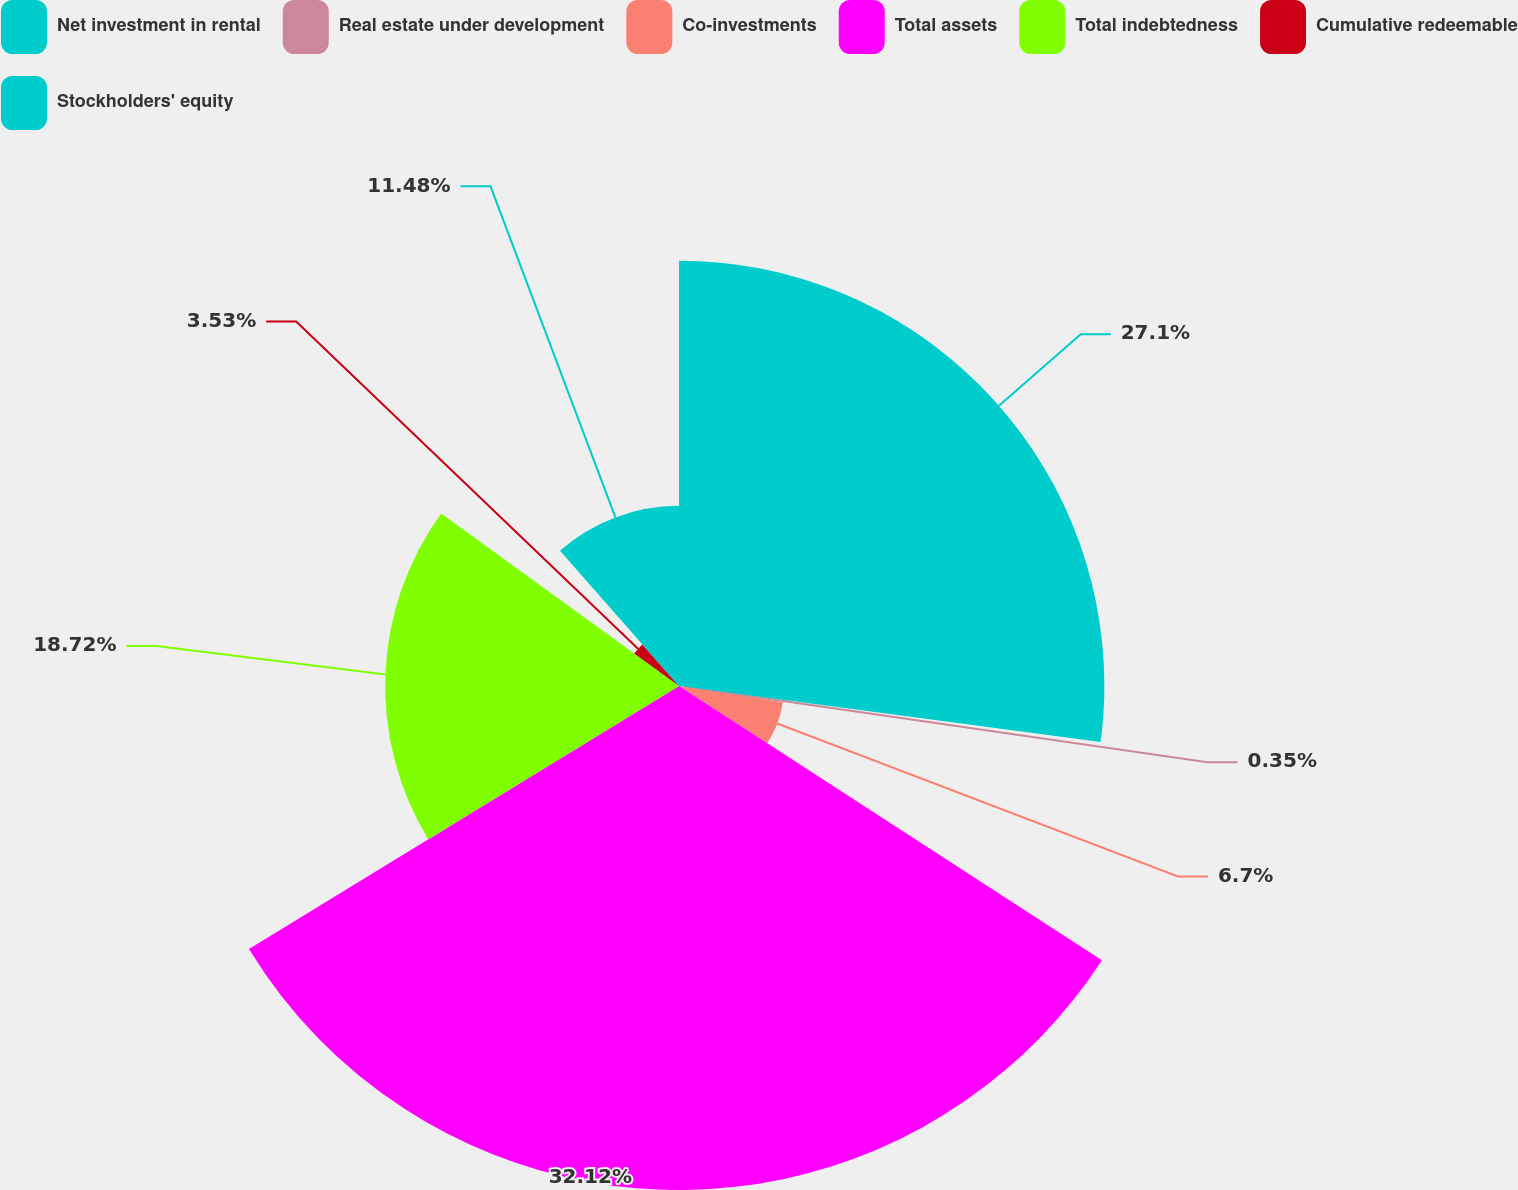<chart> <loc_0><loc_0><loc_500><loc_500><pie_chart><fcel>Net investment in rental<fcel>Real estate under development<fcel>Co-investments<fcel>Total assets<fcel>Total indebtedness<fcel>Cumulative redeemable<fcel>Stockholders' equity<nl><fcel>27.1%<fcel>0.35%<fcel>6.7%<fcel>32.11%<fcel>18.72%<fcel>3.53%<fcel>11.48%<nl></chart> 